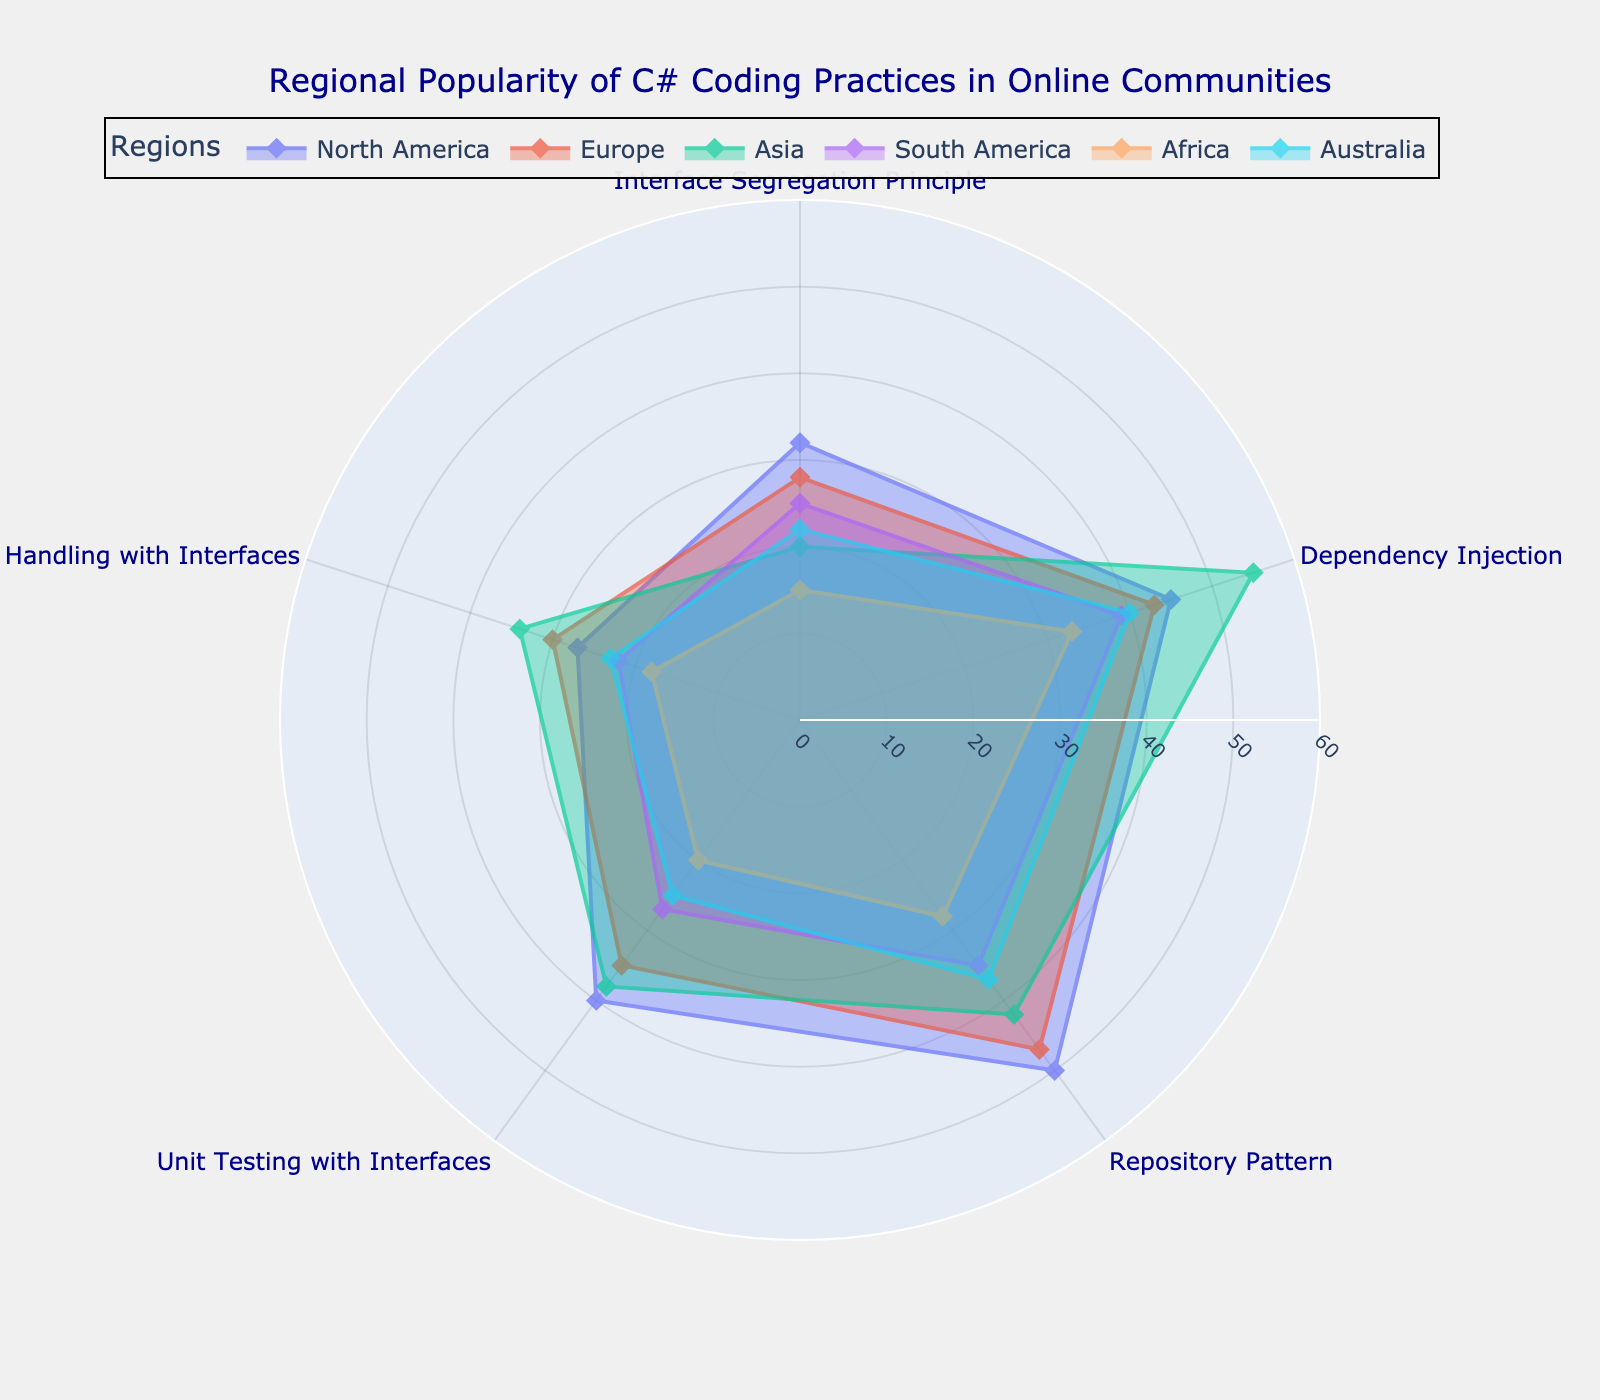What is the title of the figure? The title of the figure is located at the top center and it generally describes what the figure represents. In this case, the title is "Regional Popularity of C# Coding Practices in Online Communities".
Answer: Regional Popularity of C# Coding Practices in Online Communities Which region has the highest reported value for Dependency Injection? To determine this, we look at the data points corresponding to Dependency Injection for each region. Asia has the highest value of 55.
Answer: Asia Compare the popularity of Unit Testing with Interfaces between North America and Europe. We locate the values for Unit Testing with Interfaces in both North America and Europe. North America has 40, and Europe has 35. Therefore, North America has a higher value.
Answer: North America What is the average value for Repository Pattern across all regions? To find the average, sum the Repository Pattern values (50, 47, 42, 35, 28, 37) and divide by the number of regions (6). Calculation: (50 + 47 + 42 + 35 + 28 + 37) / 6 = 239 / 6 = 39.83 approximately.
Answer: 39.83 For the Interface Segregation Principle, which region reports the lowest value? We examine the values for Interface Segregation Principle across all regions. Africa has the lowest value of 15.
Answer: Africa How much greater is the popularity of Event Handling with Interfaces in Asia compared to Australia? We find the value for Event Handling with Interfaces in Asia (34) and Australia (23), then subtract the smaller from the larger. Calculation: 34 - 23 = 11.
Answer: 11 Which coding practice reaches the highest popularity across all regions? To find the coding practice with the highest popularity value, we need to inspect each maximum value for each practice. Dependency Injection in Asia has the highest value of 55.
Answer: Dependency Injection in Asia Does any region report equally for both Interface Segregation Principle and Event Handling with Interfaces? We compare the values for Interface Segregation Principle and Event Handling with Interfaces for each region. No region has equal values for these two practices.
Answer: No What's the range of values for Dependency Injection across all regions? The range is calculated by subtracting the minimum value from the maximum value. Maximum value for Dependency Injection is 55 (Asia) and the minimum is 33 (Africa). Calculation: 55 - 33 = 22.
Answer: 22 What is the most popular C# coding practice in North America? To find this, we compare the values for each practice in North America. Repository Pattern has the highest value of 50.
Answer: Repository Pattern 